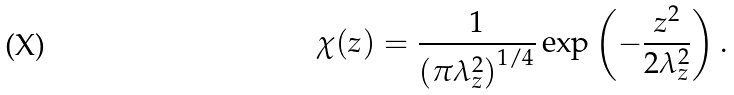<formula> <loc_0><loc_0><loc_500><loc_500>\chi { \left ( z \right ) } & = \frac { 1 } { \left ( \pi \lambda _ { z } ^ { 2 } \right ) ^ { 1 / 4 } } \exp { \left ( - \frac { z ^ { 2 } } { 2 \lambda _ { z } ^ { 2 } } \right ) } \, .</formula> 